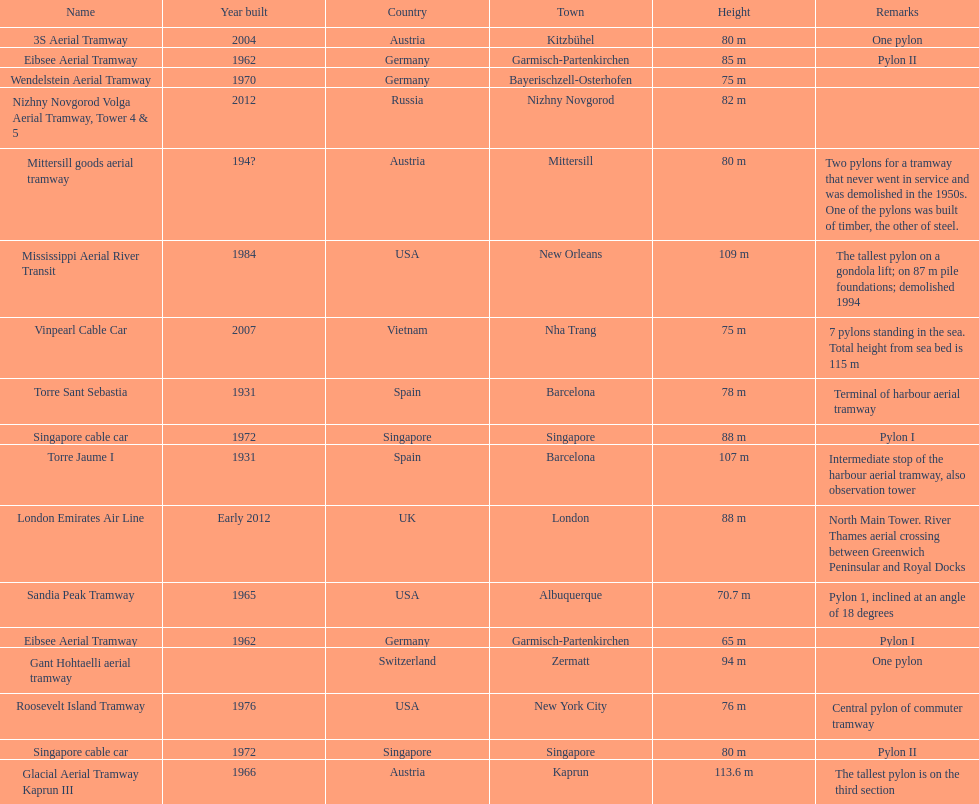How many pylons are at least 80 meters tall? 11. 